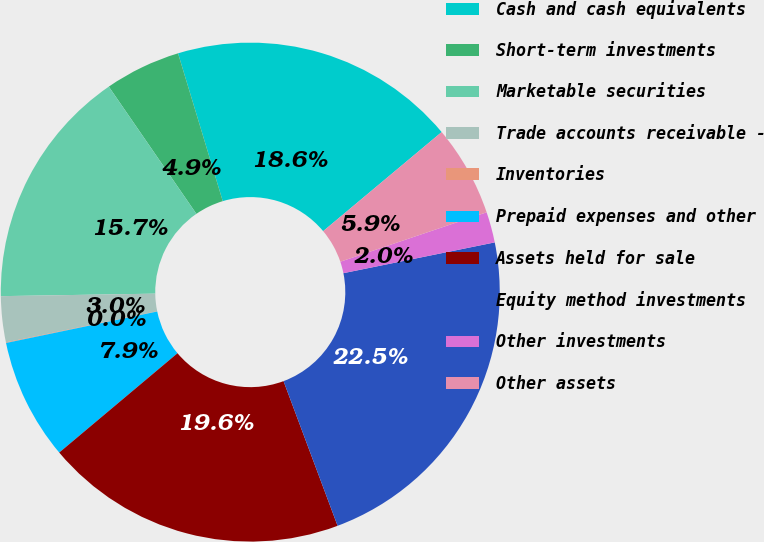Convert chart to OTSL. <chart><loc_0><loc_0><loc_500><loc_500><pie_chart><fcel>Cash and cash equivalents<fcel>Short-term investments<fcel>Marketable securities<fcel>Trade accounts receivable -<fcel>Inventories<fcel>Prepaid expenses and other<fcel>Assets held for sale<fcel>Equity method investments<fcel>Other investments<fcel>Other assets<nl><fcel>18.59%<fcel>4.92%<fcel>15.66%<fcel>2.97%<fcel>0.04%<fcel>7.85%<fcel>19.57%<fcel>22.5%<fcel>1.99%<fcel>5.9%<nl></chart> 